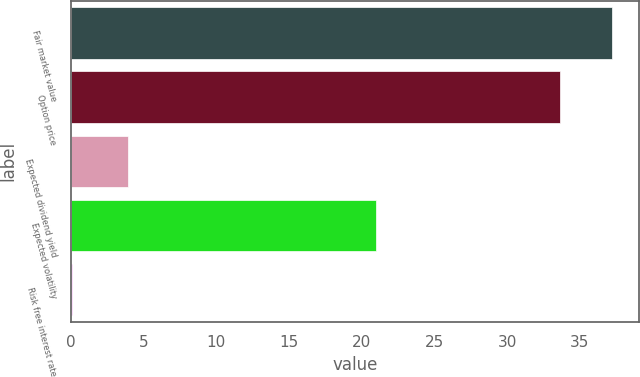Convert chart to OTSL. <chart><loc_0><loc_0><loc_500><loc_500><bar_chart><fcel>Fair market value<fcel>Option price<fcel>Expected dividend yield<fcel>Expected volatility<fcel>Risk free interest rate<nl><fcel>37.2<fcel>33.66<fcel>3.9<fcel>21<fcel>0.07<nl></chart> 